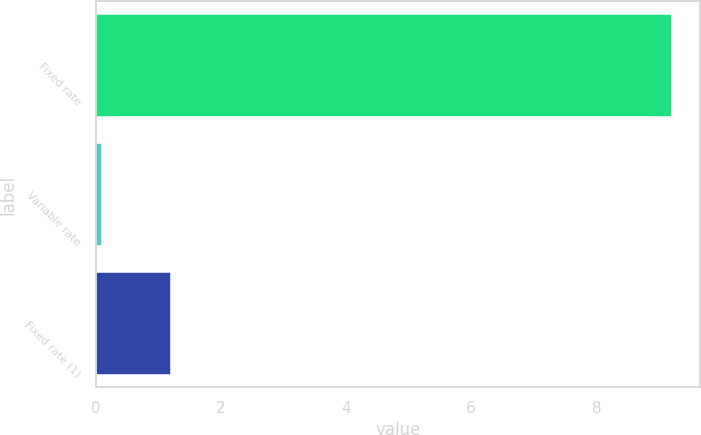<chart> <loc_0><loc_0><loc_500><loc_500><bar_chart><fcel>Fixed rate<fcel>Variable rate<fcel>Fixed rate (1)<nl><fcel>9.2<fcel>0.1<fcel>1.2<nl></chart> 